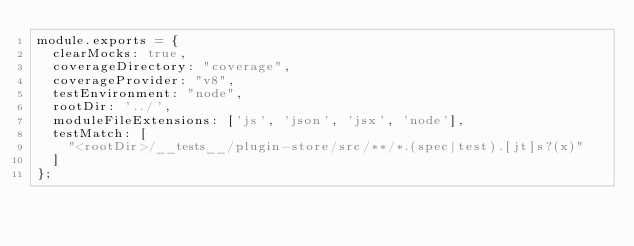Convert code to text. <code><loc_0><loc_0><loc_500><loc_500><_JavaScript_>module.exports = {
  clearMocks: true,
  coverageDirectory: "coverage",
  coverageProvider: "v8",
  testEnvironment: "node",
  rootDir: '../',
  moduleFileExtensions: ['js', 'json', 'jsx', 'node'],
  testMatch: [
    "<rootDir>/__tests__/plugin-store/src/**/*.(spec|test).[jt]s?(x)"
  ]
};</code> 